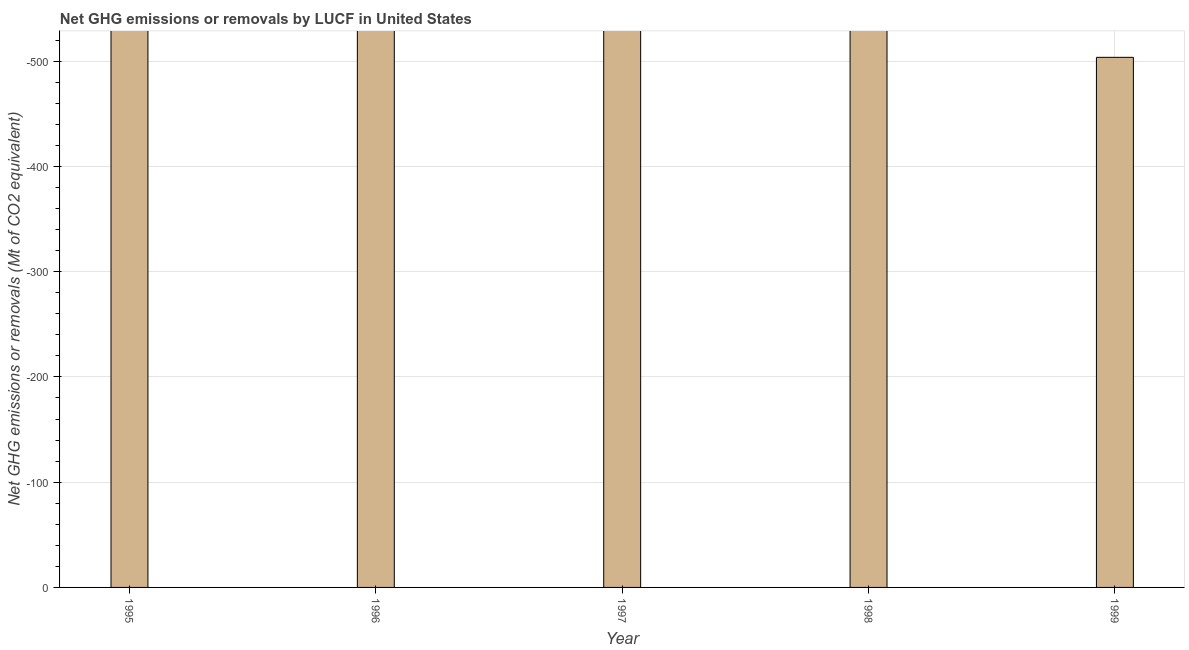What is the title of the graph?
Offer a very short reply. Net GHG emissions or removals by LUCF in United States. What is the label or title of the Y-axis?
Offer a very short reply. Net GHG emissions or removals (Mt of CO2 equivalent). What is the ghg net emissions or removals in 1999?
Offer a terse response. 0. Across all years, what is the minimum ghg net emissions or removals?
Offer a very short reply. 0. What is the sum of the ghg net emissions or removals?
Offer a terse response. 0. What is the average ghg net emissions or removals per year?
Provide a succinct answer. 0. In how many years, is the ghg net emissions or removals greater than -160 Mt?
Your response must be concise. 0. In how many years, is the ghg net emissions or removals greater than the average ghg net emissions or removals taken over all years?
Your answer should be very brief. 0. How many bars are there?
Ensure brevity in your answer.  0. Are all the bars in the graph horizontal?
Ensure brevity in your answer.  No. Are the values on the major ticks of Y-axis written in scientific E-notation?
Provide a succinct answer. No. What is the Net GHG emissions or removals (Mt of CO2 equivalent) of 1997?
Provide a short and direct response. 0. What is the Net GHG emissions or removals (Mt of CO2 equivalent) of 1999?
Give a very brief answer. 0. 